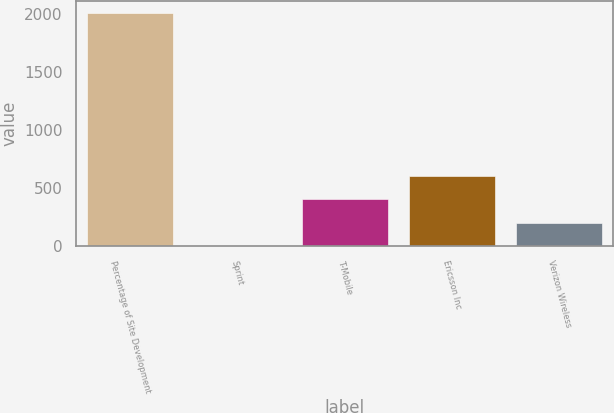<chart> <loc_0><loc_0><loc_500><loc_500><bar_chart><fcel>Percentage of Site Development<fcel>Sprint<fcel>T-Mobile<fcel>Ericsson Inc<fcel>Verizon Wireless<nl><fcel>2013<fcel>1.5<fcel>403.8<fcel>604.95<fcel>202.65<nl></chart> 